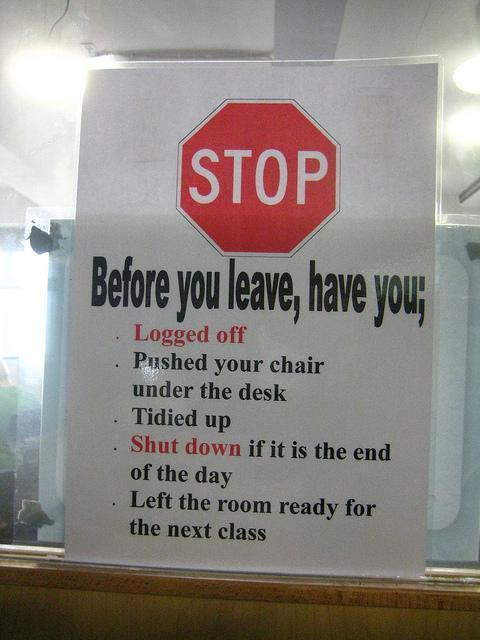How many people in the image can be clearly seen wearing mariners jerseys?
Give a very brief answer. 0. 